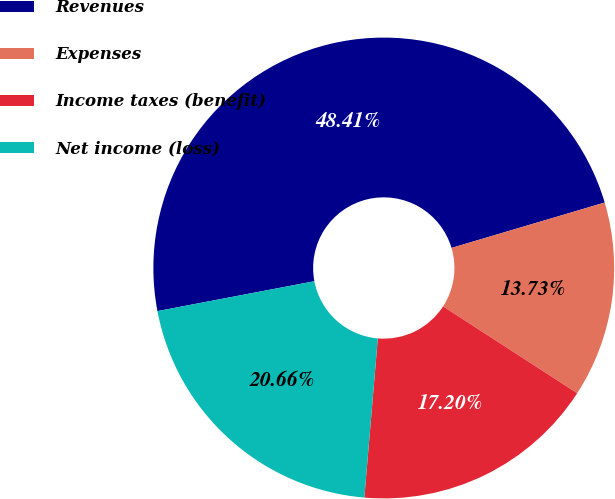<chart> <loc_0><loc_0><loc_500><loc_500><pie_chart><fcel>Revenues<fcel>Expenses<fcel>Income taxes (benefit)<fcel>Net income (loss)<nl><fcel>48.41%<fcel>13.73%<fcel>17.2%<fcel>20.66%<nl></chart> 